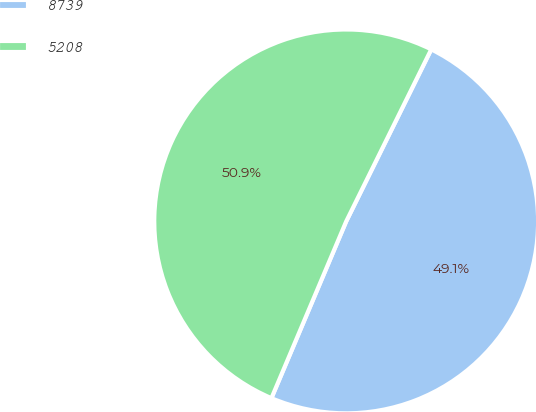Convert chart to OTSL. <chart><loc_0><loc_0><loc_500><loc_500><pie_chart><fcel>8739<fcel>5208<nl><fcel>49.06%<fcel>50.94%<nl></chart> 